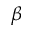Convert formula to latex. <formula><loc_0><loc_0><loc_500><loc_500>\beta</formula> 